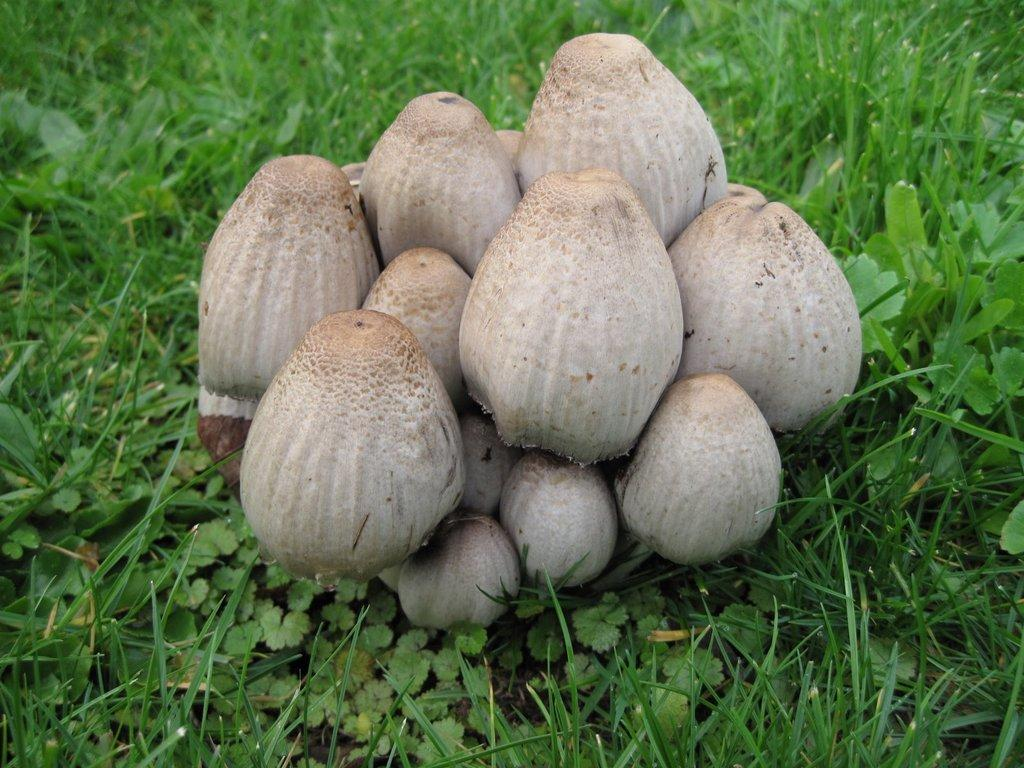What type of fungi can be seen in the image? There are mushrooms in the image. What type of vegetation is visible in the background of the image? Grass and leaves are present in the background of the image. What type of birthday verse can be seen written on the mushrooms in the image? There is no birthday verse or any writing present on the mushrooms in the image. 